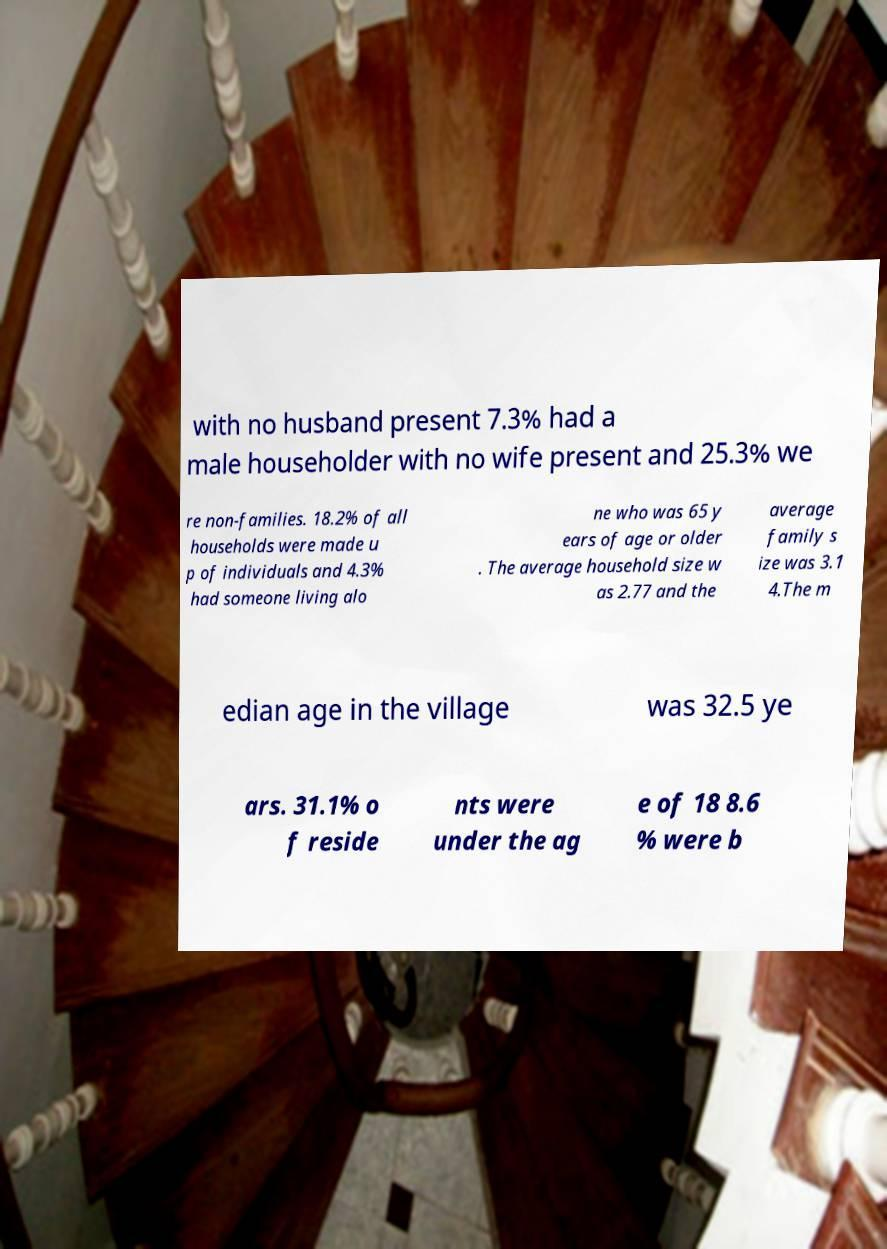Please read and relay the text visible in this image. What does it say? with no husband present 7.3% had a male householder with no wife present and 25.3% we re non-families. 18.2% of all households were made u p of individuals and 4.3% had someone living alo ne who was 65 y ears of age or older . The average household size w as 2.77 and the average family s ize was 3.1 4.The m edian age in the village was 32.5 ye ars. 31.1% o f reside nts were under the ag e of 18 8.6 % were b 